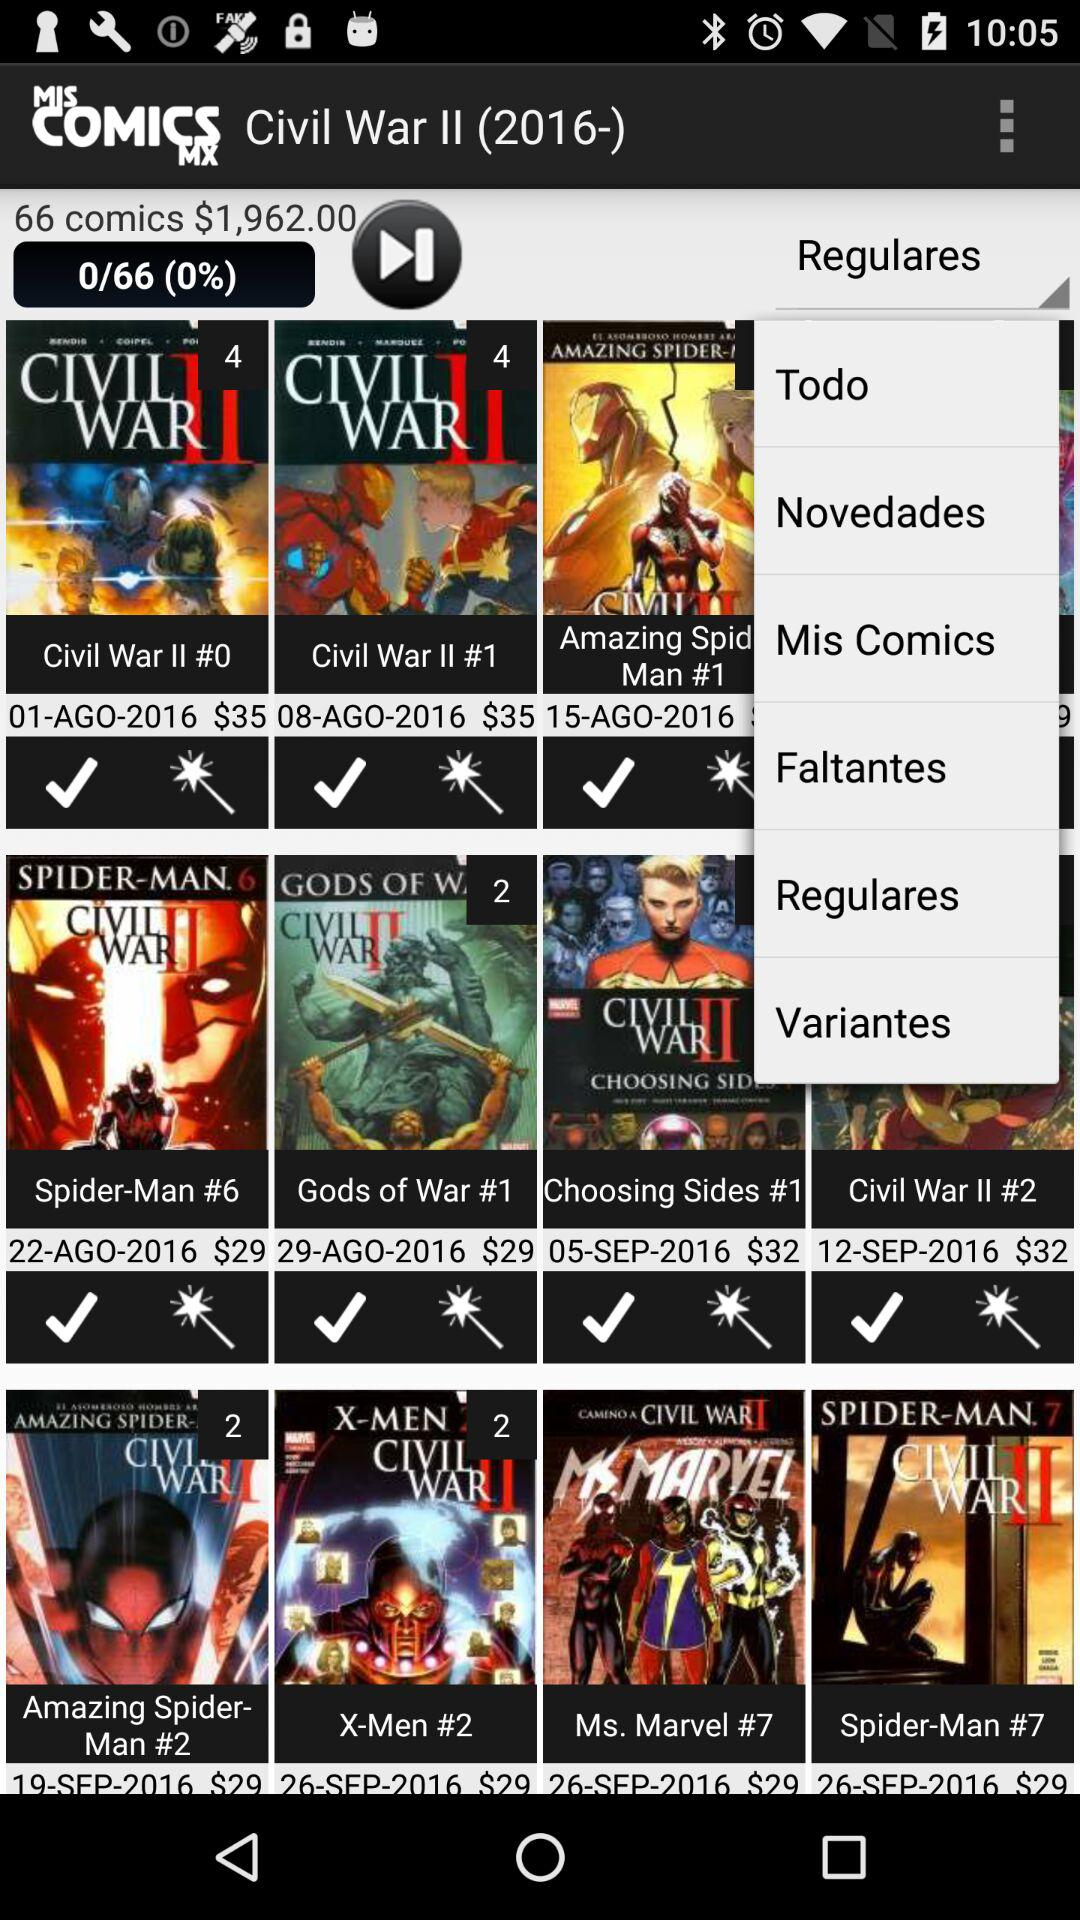What is the price of the "Civil War II #0" comic? The price of the comic is $35. 